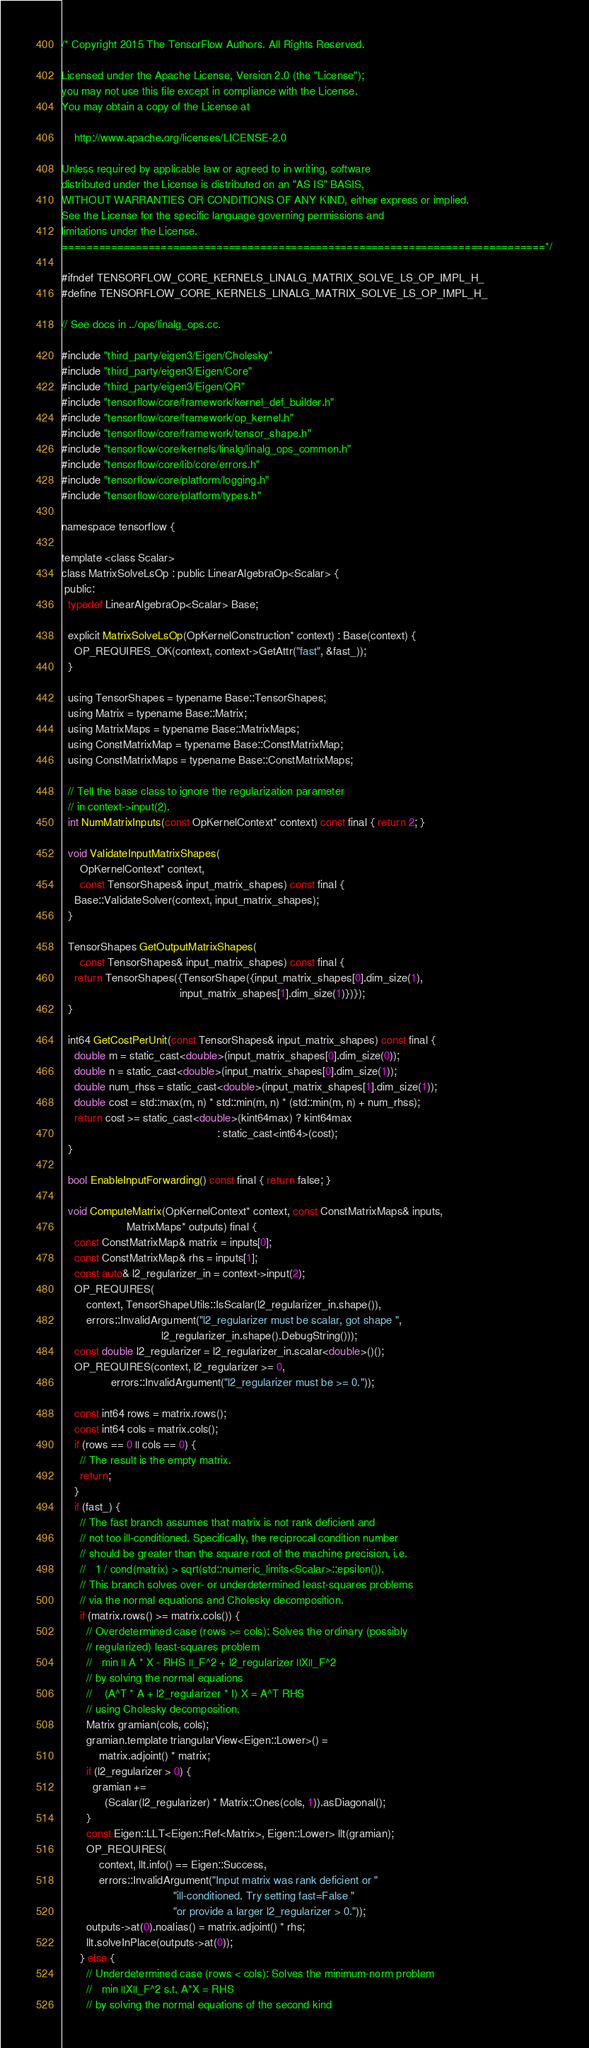Convert code to text. <code><loc_0><loc_0><loc_500><loc_500><_C_>/* Copyright 2015 The TensorFlow Authors. All Rights Reserved.

Licensed under the Apache License, Version 2.0 (the "License");
you may not use this file except in compliance with the License.
You may obtain a copy of the License at

    http://www.apache.org/licenses/LICENSE-2.0

Unless required by applicable law or agreed to in writing, software
distributed under the License is distributed on an "AS IS" BASIS,
WITHOUT WARRANTIES OR CONDITIONS OF ANY KIND, either express or implied.
See the License for the specific language governing permissions and
limitations under the License.
==============================================================================*/

#ifndef TENSORFLOW_CORE_KERNELS_LINALG_MATRIX_SOLVE_LS_OP_IMPL_H_
#define TENSORFLOW_CORE_KERNELS_LINALG_MATRIX_SOLVE_LS_OP_IMPL_H_

// See docs in ../ops/linalg_ops.cc.

#include "third_party/eigen3/Eigen/Cholesky"
#include "third_party/eigen3/Eigen/Core"
#include "third_party/eigen3/Eigen/QR"
#include "tensorflow/core/framework/kernel_def_builder.h"
#include "tensorflow/core/framework/op_kernel.h"
#include "tensorflow/core/framework/tensor_shape.h"
#include "tensorflow/core/kernels/linalg/linalg_ops_common.h"
#include "tensorflow/core/lib/core/errors.h"
#include "tensorflow/core/platform/logging.h"
#include "tensorflow/core/platform/types.h"

namespace tensorflow {

template <class Scalar>
class MatrixSolveLsOp : public LinearAlgebraOp<Scalar> {
 public:
  typedef LinearAlgebraOp<Scalar> Base;

  explicit MatrixSolveLsOp(OpKernelConstruction* context) : Base(context) {
    OP_REQUIRES_OK(context, context->GetAttr("fast", &fast_));
  }

  using TensorShapes = typename Base::TensorShapes;
  using Matrix = typename Base::Matrix;
  using MatrixMaps = typename Base::MatrixMaps;
  using ConstMatrixMap = typename Base::ConstMatrixMap;
  using ConstMatrixMaps = typename Base::ConstMatrixMaps;

  // Tell the base class to ignore the regularization parameter
  // in context->input(2).
  int NumMatrixInputs(const OpKernelContext* context) const final { return 2; }

  void ValidateInputMatrixShapes(
      OpKernelContext* context,
      const TensorShapes& input_matrix_shapes) const final {
    Base::ValidateSolver(context, input_matrix_shapes);
  }

  TensorShapes GetOutputMatrixShapes(
      const TensorShapes& input_matrix_shapes) const final {
    return TensorShapes({TensorShape({input_matrix_shapes[0].dim_size(1),
                                      input_matrix_shapes[1].dim_size(1)})});
  }

  int64 GetCostPerUnit(const TensorShapes& input_matrix_shapes) const final {
    double m = static_cast<double>(input_matrix_shapes[0].dim_size(0));
    double n = static_cast<double>(input_matrix_shapes[0].dim_size(1));
    double num_rhss = static_cast<double>(input_matrix_shapes[1].dim_size(1));
    double cost = std::max(m, n) * std::min(m, n) * (std::min(m, n) + num_rhss);
    return cost >= static_cast<double>(kint64max) ? kint64max
                                                  : static_cast<int64>(cost);
  }

  bool EnableInputForwarding() const final { return false; }

  void ComputeMatrix(OpKernelContext* context, const ConstMatrixMaps& inputs,
                     MatrixMaps* outputs) final {
    const ConstMatrixMap& matrix = inputs[0];
    const ConstMatrixMap& rhs = inputs[1];
    const auto& l2_regularizer_in = context->input(2);
    OP_REQUIRES(
        context, TensorShapeUtils::IsScalar(l2_regularizer_in.shape()),
        errors::InvalidArgument("l2_regularizer must be scalar, got shape ",
                                l2_regularizer_in.shape().DebugString()));
    const double l2_regularizer = l2_regularizer_in.scalar<double>()();
    OP_REQUIRES(context, l2_regularizer >= 0,
                errors::InvalidArgument("l2_regularizer must be >= 0."));

    const int64 rows = matrix.rows();
    const int64 cols = matrix.cols();
    if (rows == 0 || cols == 0) {
      // The result is the empty matrix.
      return;
    }
    if (fast_) {
      // The fast branch assumes that matrix is not rank deficient and
      // not too ill-conditioned. Specifically, the reciprocal condition number
      // should be greater than the square root of the machine precision, i.e.
      //   1 / cond(matrix) > sqrt(std::numeric_limits<Scalar>::epsilon()).
      // This branch solves over- or underdetermined least-squares problems
      // via the normal equations and Cholesky decomposition.
      if (matrix.rows() >= matrix.cols()) {
        // Overdetermined case (rows >= cols): Solves the ordinary (possibly
        // regularized) least-squares problem
        //   min || A * X - RHS ||_F^2 + l2_regularizer ||X||_F^2
        // by solving the normal equations
        //    (A^T * A + l2_regularizer * I) X = A^T RHS
        // using Cholesky decomposition.
        Matrix gramian(cols, cols);
        gramian.template triangularView<Eigen::Lower>() =
            matrix.adjoint() * matrix;
        if (l2_regularizer > 0) {
          gramian +=
              (Scalar(l2_regularizer) * Matrix::Ones(cols, 1)).asDiagonal();
        }
        const Eigen::LLT<Eigen::Ref<Matrix>, Eigen::Lower> llt(gramian);
        OP_REQUIRES(
            context, llt.info() == Eigen::Success,
            errors::InvalidArgument("Input matrix was rank deficient or "
                                    "ill-conditioned. Try setting fast=False "
                                    "or provide a larger l2_regularizer > 0."));
        outputs->at(0).noalias() = matrix.adjoint() * rhs;
        llt.solveInPlace(outputs->at(0));
      } else {
        // Underdetermined case (rows < cols): Solves the minimum-norm problem
        //   min ||X||_F^2 s.t. A*X = RHS
        // by solving the normal equations of the second kind</code> 